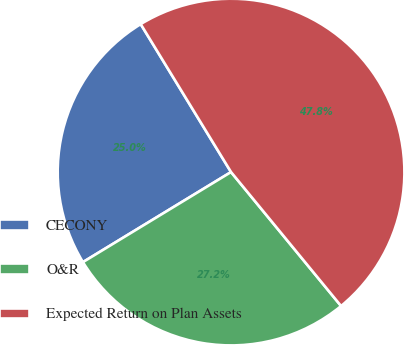Convert chart to OTSL. <chart><loc_0><loc_0><loc_500><loc_500><pie_chart><fcel>CECONY<fcel>O&R<fcel>Expected Return on Plan Assets<nl><fcel>24.97%<fcel>27.25%<fcel>47.78%<nl></chart> 